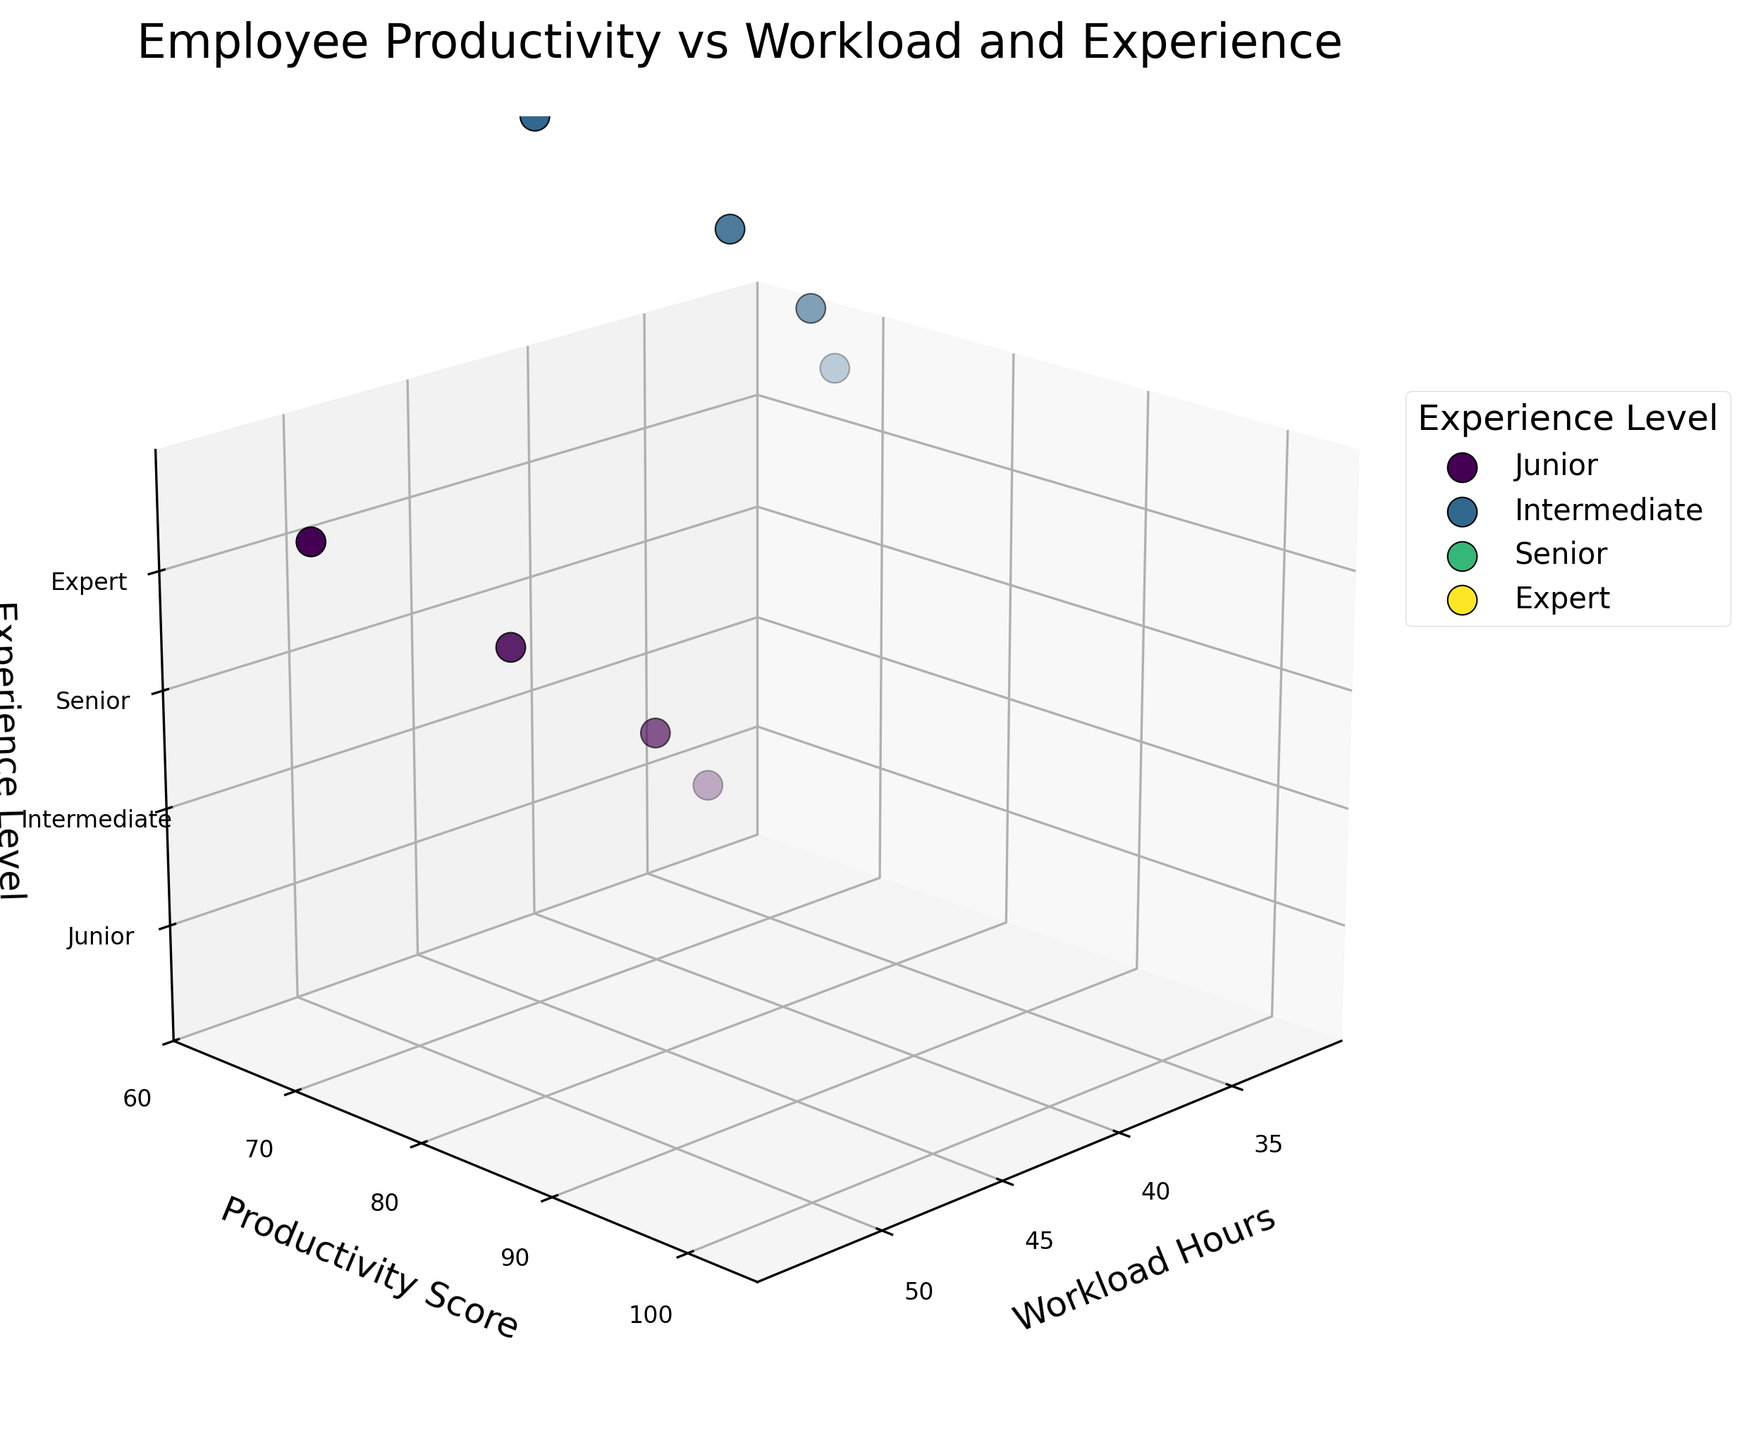What is the title of the figure? The title is located at the top of the figure. It is a textual caption summarizing the content of the plot.
Answer: Employee Productivity vs Workload and Experience How many experience levels are shown in the plot? The experience levels are represented by different colored points in the 3D space, and there is a legend indicating each level. Count the unique labels in the legend.
Answer: Four Which experience level has the highest productivity score? Examine the data points in the Y-axis (Productivity Score) and check the maximum value. Compare the corresponding experience level from the Z-axis label.
Answer: Expert What is the productivity score for a Senior employee working 40 hours? Locate the data point at 40 hours on the X-axis, then check the corresponding Y-axis value for the blue-colored data point, denoted for Senior level.
Answer: 92 What is the average productivity score for Expert-level employees? Identify the productivity scores for Expert level (90, 98, 100, 97), sum them up, and then divide by the number of data points.
Answer: 96.25 Which experience level shows the largest range in productivity scores? For each experience level, subtract the minimum productivity score from the maximum productivity score. Compare these ranges across all levels.
Answer: Expert If a Junior employee's workload increases from 35 to 50 hours, what happens to their productivity score? Compare the productivity scores of Junior level employees at 35 hours (65) and 50 hours (62). Observe the trend between these points on the Y-axis.
Answer: Decreases Which experience level has the least variation in productivity scores? Calculate the variance or standard deviation of the productivity scores for each experience level. Compare to find the smallest value.
Answer: Junior How does productivity change with workload for Intermediate and Expert levels? Observe the slope or trend of data points for Intermediate and Expert levels. Compare how productivity scores on the Y-axis change as workload hours on the X-axis increase.
Answer: Increases for both Are there any data points where the productivity score is less than 70? If yes, for which experience levels? Look for points on the Y-axis that are less than 70, then check the corresponding experience levels from the Z-axis or color.
Answer: Junior 